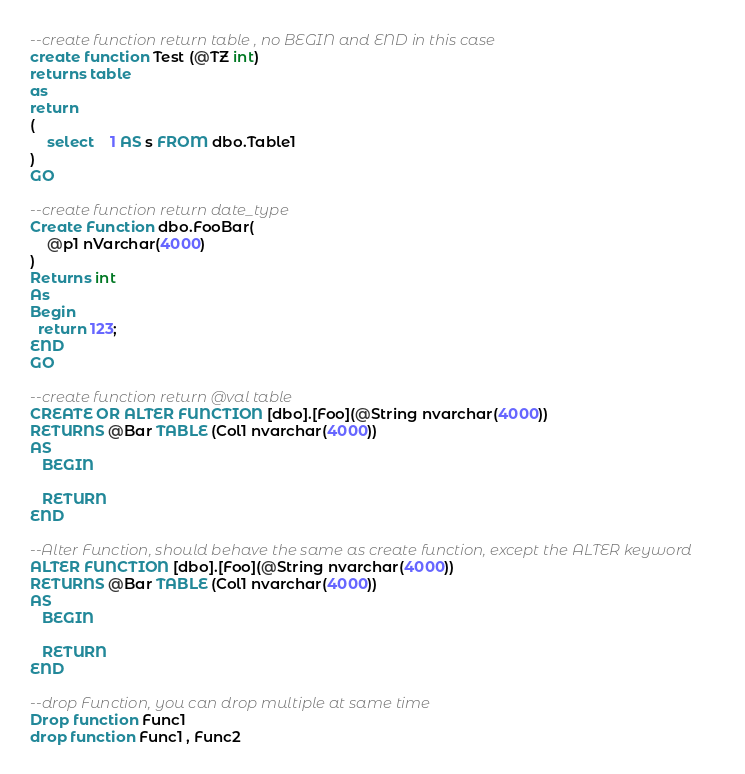Convert code to text. <code><loc_0><loc_0><loc_500><loc_500><_SQL_>
--create function return table , no BEGIN and END in this case
create function Test (@TZ int)
returns table
as
return
(
	select	1 AS s FROM dbo.Table1
)
GO

--create function return date_type
Create Function dbo.FooBar(
    @p1 nVarchar(4000)
)
Returns int
As
Begin
  return 123;
END
GO

--create function return @val table 
CREATE OR ALTER FUNCTION [dbo].[Foo](@String nvarchar(4000))
RETURNS @Bar TABLE (Col1 nvarchar(4000))
AS
   BEGIN

   RETURN
END

--Alter Function, should behave the same as create function, except the ALTER keyword
ALTER FUNCTION [dbo].[Foo](@String nvarchar(4000))
RETURNS @Bar TABLE (Col1 nvarchar(4000))
AS
   BEGIN

   RETURN
END

--drop Function, you can drop multiple at same time
Drop function Func1 
drop function Func1 , Func2
</code> 